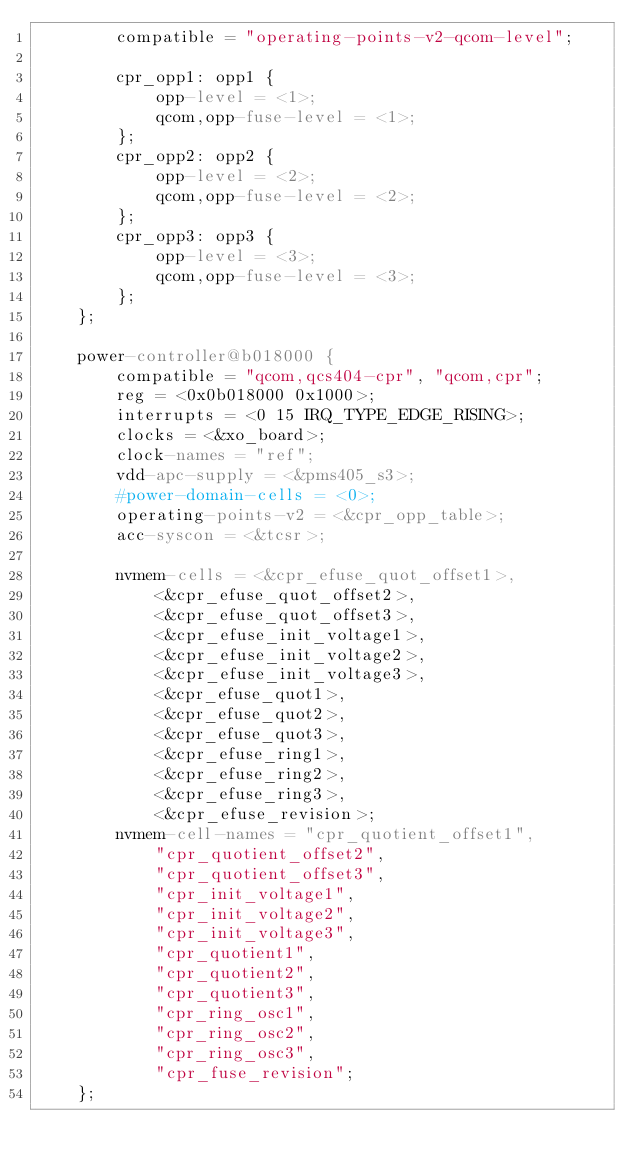Convert code to text. <code><loc_0><loc_0><loc_500><loc_500><_YAML_>        compatible = "operating-points-v2-qcom-level";

        cpr_opp1: opp1 {
            opp-level = <1>;
            qcom,opp-fuse-level = <1>;
        };
        cpr_opp2: opp2 {
            opp-level = <2>;
            qcom,opp-fuse-level = <2>;
        };
        cpr_opp3: opp3 {
            opp-level = <3>;
            qcom,opp-fuse-level = <3>;
        };
    };

    power-controller@b018000 {
        compatible = "qcom,qcs404-cpr", "qcom,cpr";
        reg = <0x0b018000 0x1000>;
        interrupts = <0 15 IRQ_TYPE_EDGE_RISING>;
        clocks = <&xo_board>;
        clock-names = "ref";
        vdd-apc-supply = <&pms405_s3>;
        #power-domain-cells = <0>;
        operating-points-v2 = <&cpr_opp_table>;
        acc-syscon = <&tcsr>;

        nvmem-cells = <&cpr_efuse_quot_offset1>,
            <&cpr_efuse_quot_offset2>,
            <&cpr_efuse_quot_offset3>,
            <&cpr_efuse_init_voltage1>,
            <&cpr_efuse_init_voltage2>,
            <&cpr_efuse_init_voltage3>,
            <&cpr_efuse_quot1>,
            <&cpr_efuse_quot2>,
            <&cpr_efuse_quot3>,
            <&cpr_efuse_ring1>,
            <&cpr_efuse_ring2>,
            <&cpr_efuse_ring3>,
            <&cpr_efuse_revision>;
        nvmem-cell-names = "cpr_quotient_offset1",
            "cpr_quotient_offset2",
            "cpr_quotient_offset3",
            "cpr_init_voltage1",
            "cpr_init_voltage2",
            "cpr_init_voltage3",
            "cpr_quotient1",
            "cpr_quotient2",
            "cpr_quotient3",
            "cpr_ring_osc1",
            "cpr_ring_osc2",
            "cpr_ring_osc3",
            "cpr_fuse_revision";
    };
</code> 